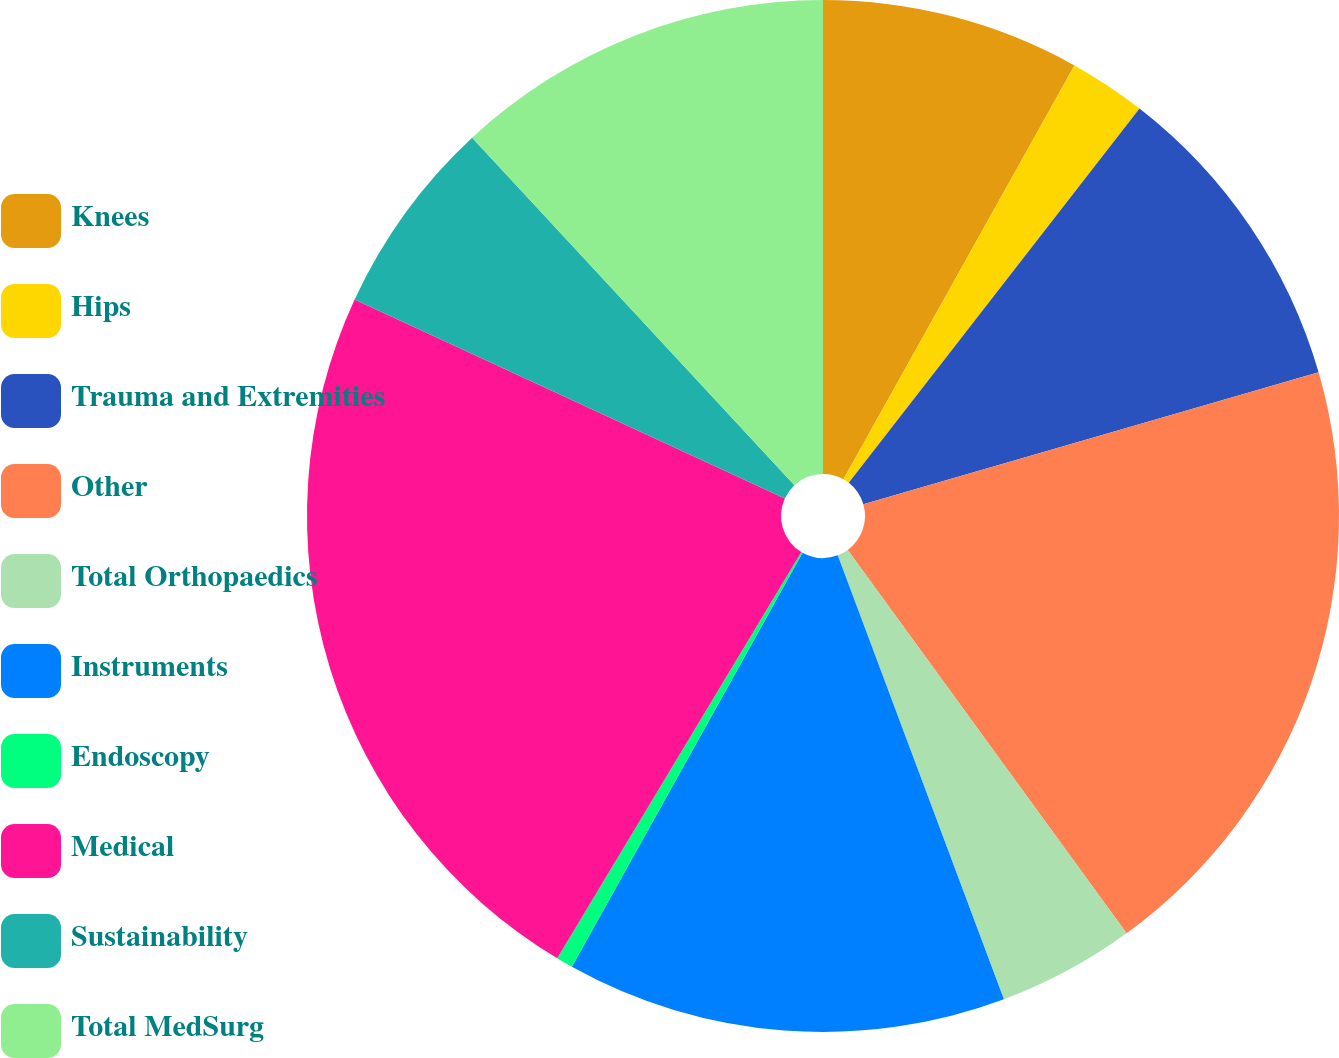<chart> <loc_0><loc_0><loc_500><loc_500><pie_chart><fcel>Knees<fcel>Hips<fcel>Trauma and Extremities<fcel>Other<fcel>Total Orthopaedics<fcel>Instruments<fcel>Endoscopy<fcel>Medical<fcel>Sustainability<fcel>Total MedSurg<nl><fcel>8.1%<fcel>2.41%<fcel>10.0%<fcel>19.48%<fcel>4.31%<fcel>13.79%<fcel>0.52%<fcel>23.28%<fcel>6.21%<fcel>11.9%<nl></chart> 